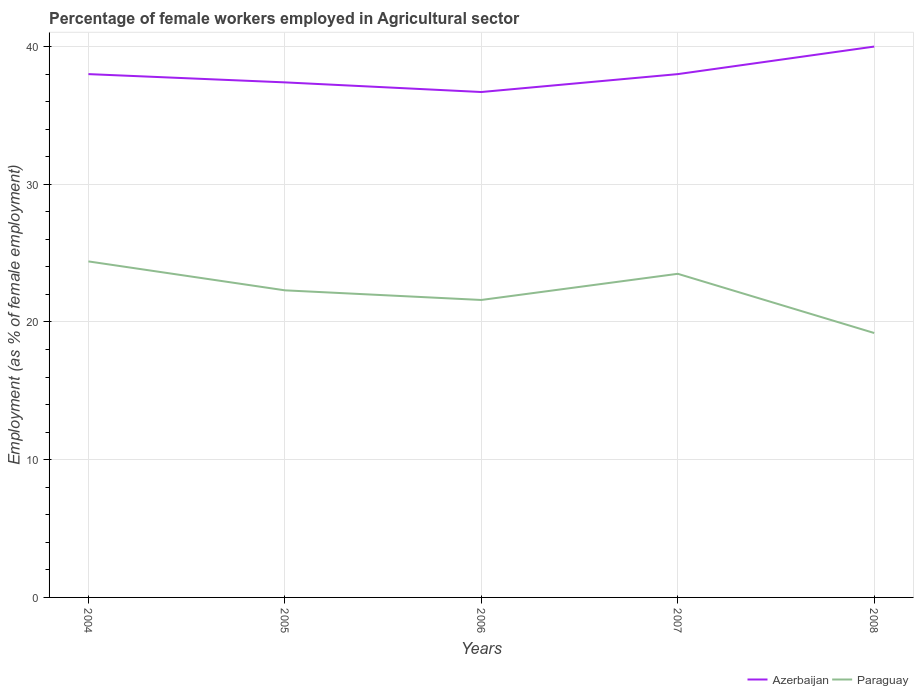Does the line corresponding to Paraguay intersect with the line corresponding to Azerbaijan?
Your response must be concise. No. Across all years, what is the maximum percentage of females employed in Agricultural sector in Azerbaijan?
Provide a short and direct response. 36.7. What is the total percentage of females employed in Agricultural sector in Paraguay in the graph?
Keep it short and to the point. 2.8. What is the difference between the highest and the second highest percentage of females employed in Agricultural sector in Paraguay?
Your response must be concise. 5.2. What is the difference between the highest and the lowest percentage of females employed in Agricultural sector in Azerbaijan?
Your answer should be very brief. 1. What is the difference between two consecutive major ticks on the Y-axis?
Your answer should be very brief. 10. Does the graph contain any zero values?
Keep it short and to the point. No. Does the graph contain grids?
Give a very brief answer. Yes. How many legend labels are there?
Your answer should be compact. 2. How are the legend labels stacked?
Ensure brevity in your answer.  Horizontal. What is the title of the graph?
Offer a terse response. Percentage of female workers employed in Agricultural sector. What is the label or title of the Y-axis?
Your response must be concise. Employment (as % of female employment). What is the Employment (as % of female employment) in Paraguay in 2004?
Offer a very short reply. 24.4. What is the Employment (as % of female employment) of Azerbaijan in 2005?
Provide a succinct answer. 37.4. What is the Employment (as % of female employment) of Paraguay in 2005?
Your answer should be compact. 22.3. What is the Employment (as % of female employment) in Azerbaijan in 2006?
Give a very brief answer. 36.7. What is the Employment (as % of female employment) of Paraguay in 2006?
Your answer should be very brief. 21.6. What is the Employment (as % of female employment) in Azerbaijan in 2007?
Make the answer very short. 38. What is the Employment (as % of female employment) of Paraguay in 2008?
Keep it short and to the point. 19.2. Across all years, what is the maximum Employment (as % of female employment) in Paraguay?
Your response must be concise. 24.4. Across all years, what is the minimum Employment (as % of female employment) in Azerbaijan?
Give a very brief answer. 36.7. Across all years, what is the minimum Employment (as % of female employment) of Paraguay?
Your answer should be compact. 19.2. What is the total Employment (as % of female employment) of Azerbaijan in the graph?
Your response must be concise. 190.1. What is the total Employment (as % of female employment) of Paraguay in the graph?
Keep it short and to the point. 111. What is the difference between the Employment (as % of female employment) in Azerbaijan in 2004 and that in 2005?
Provide a succinct answer. 0.6. What is the difference between the Employment (as % of female employment) in Paraguay in 2004 and that in 2005?
Give a very brief answer. 2.1. What is the difference between the Employment (as % of female employment) of Azerbaijan in 2004 and that in 2006?
Ensure brevity in your answer.  1.3. What is the difference between the Employment (as % of female employment) of Paraguay in 2004 and that in 2006?
Offer a terse response. 2.8. What is the difference between the Employment (as % of female employment) in Paraguay in 2004 and that in 2007?
Make the answer very short. 0.9. What is the difference between the Employment (as % of female employment) in Azerbaijan in 2004 and that in 2008?
Your response must be concise. -2. What is the difference between the Employment (as % of female employment) of Paraguay in 2005 and that in 2007?
Keep it short and to the point. -1.2. What is the difference between the Employment (as % of female employment) of Paraguay in 2005 and that in 2008?
Your answer should be very brief. 3.1. What is the difference between the Employment (as % of female employment) of Paraguay in 2006 and that in 2007?
Offer a terse response. -1.9. What is the difference between the Employment (as % of female employment) in Paraguay in 2006 and that in 2008?
Offer a terse response. 2.4. What is the difference between the Employment (as % of female employment) of Paraguay in 2007 and that in 2008?
Ensure brevity in your answer.  4.3. What is the difference between the Employment (as % of female employment) in Azerbaijan in 2004 and the Employment (as % of female employment) in Paraguay in 2006?
Keep it short and to the point. 16.4. What is the difference between the Employment (as % of female employment) in Azerbaijan in 2004 and the Employment (as % of female employment) in Paraguay in 2007?
Ensure brevity in your answer.  14.5. What is the difference between the Employment (as % of female employment) in Azerbaijan in 2004 and the Employment (as % of female employment) in Paraguay in 2008?
Your answer should be compact. 18.8. What is the difference between the Employment (as % of female employment) in Azerbaijan in 2005 and the Employment (as % of female employment) in Paraguay in 2006?
Ensure brevity in your answer.  15.8. What is the difference between the Employment (as % of female employment) in Azerbaijan in 2005 and the Employment (as % of female employment) in Paraguay in 2007?
Ensure brevity in your answer.  13.9. What is the difference between the Employment (as % of female employment) in Azerbaijan in 2006 and the Employment (as % of female employment) in Paraguay in 2007?
Your answer should be very brief. 13.2. What is the difference between the Employment (as % of female employment) of Azerbaijan in 2007 and the Employment (as % of female employment) of Paraguay in 2008?
Offer a terse response. 18.8. What is the average Employment (as % of female employment) in Azerbaijan per year?
Your answer should be compact. 38.02. What is the average Employment (as % of female employment) in Paraguay per year?
Offer a terse response. 22.2. In the year 2006, what is the difference between the Employment (as % of female employment) in Azerbaijan and Employment (as % of female employment) in Paraguay?
Keep it short and to the point. 15.1. In the year 2008, what is the difference between the Employment (as % of female employment) in Azerbaijan and Employment (as % of female employment) in Paraguay?
Your response must be concise. 20.8. What is the ratio of the Employment (as % of female employment) in Azerbaijan in 2004 to that in 2005?
Keep it short and to the point. 1.02. What is the ratio of the Employment (as % of female employment) in Paraguay in 2004 to that in 2005?
Provide a succinct answer. 1.09. What is the ratio of the Employment (as % of female employment) in Azerbaijan in 2004 to that in 2006?
Offer a very short reply. 1.04. What is the ratio of the Employment (as % of female employment) in Paraguay in 2004 to that in 2006?
Ensure brevity in your answer.  1.13. What is the ratio of the Employment (as % of female employment) of Azerbaijan in 2004 to that in 2007?
Offer a terse response. 1. What is the ratio of the Employment (as % of female employment) of Paraguay in 2004 to that in 2007?
Provide a succinct answer. 1.04. What is the ratio of the Employment (as % of female employment) of Paraguay in 2004 to that in 2008?
Ensure brevity in your answer.  1.27. What is the ratio of the Employment (as % of female employment) of Azerbaijan in 2005 to that in 2006?
Make the answer very short. 1.02. What is the ratio of the Employment (as % of female employment) in Paraguay in 2005 to that in 2006?
Offer a terse response. 1.03. What is the ratio of the Employment (as % of female employment) in Azerbaijan in 2005 to that in 2007?
Your answer should be very brief. 0.98. What is the ratio of the Employment (as % of female employment) of Paraguay in 2005 to that in 2007?
Ensure brevity in your answer.  0.95. What is the ratio of the Employment (as % of female employment) of Azerbaijan in 2005 to that in 2008?
Provide a succinct answer. 0.94. What is the ratio of the Employment (as % of female employment) in Paraguay in 2005 to that in 2008?
Keep it short and to the point. 1.16. What is the ratio of the Employment (as % of female employment) of Azerbaijan in 2006 to that in 2007?
Offer a very short reply. 0.97. What is the ratio of the Employment (as % of female employment) of Paraguay in 2006 to that in 2007?
Make the answer very short. 0.92. What is the ratio of the Employment (as % of female employment) in Azerbaijan in 2006 to that in 2008?
Provide a short and direct response. 0.92. What is the ratio of the Employment (as % of female employment) in Paraguay in 2007 to that in 2008?
Offer a very short reply. 1.22. What is the difference between the highest and the second highest Employment (as % of female employment) of Azerbaijan?
Ensure brevity in your answer.  2. What is the difference between the highest and the lowest Employment (as % of female employment) of Azerbaijan?
Provide a succinct answer. 3.3. What is the difference between the highest and the lowest Employment (as % of female employment) in Paraguay?
Provide a succinct answer. 5.2. 